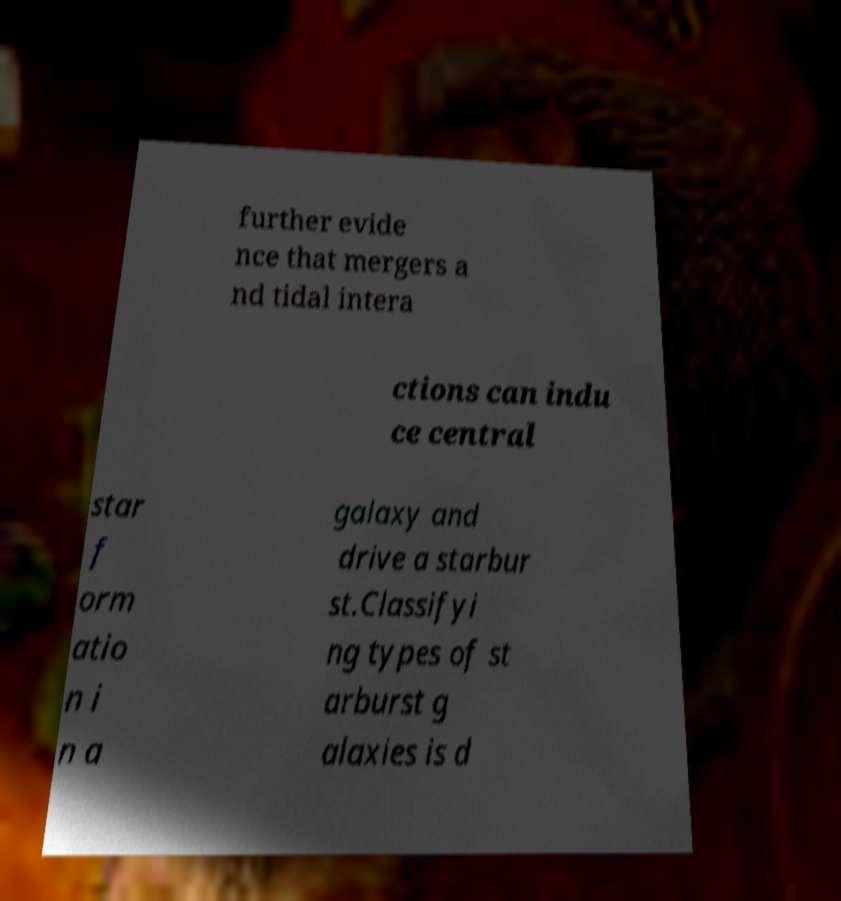What messages or text are displayed in this image? I need them in a readable, typed format. further evide nce that mergers a nd tidal intera ctions can indu ce central star f orm atio n i n a galaxy and drive a starbur st.Classifyi ng types of st arburst g alaxies is d 